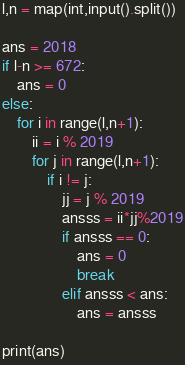<code> <loc_0><loc_0><loc_500><loc_500><_Python_>l,n = map(int,input().split())

ans = 2018
if l-n >= 672:
    ans = 0
else:
    for i in range(l,n+1):
        ii = i % 2019
        for j in range(l,n+1):
            if i != j:
                jj = j % 2019
                ansss = ii*jj%2019
                if ansss == 0:
                    ans = 0
                    break
                elif ansss < ans:
                    ans = ansss

print(ans)
</code> 